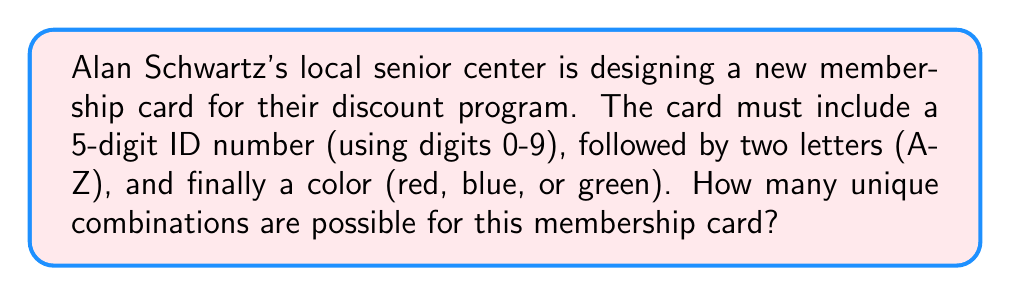What is the answer to this math problem? Let's break this down step-by-step:

1) For the 5-digit ID number:
   - We can use any digit from 0 to 9 for each position.
   - This is a case of permutation with repetition allowed.
   - Number of possibilities = $10^5$

2) For the two letters:
   - We can use any letter from A to Z for each position.
   - This is also a permutation with repetition allowed.
   - Number of possibilities = $26^2$

3) For the color:
   - We have 3 choices: red, blue, or green.
   - Number of possibilities = $3$

4) To find the total number of unique combinations, we multiply these together:

   $$ \text{Total combinations} = 10^5 \times 26^2 \times 3 $$

5) Let's calculate this:
   $$ 10^5 \times 26^2 \times 3 = 100,000 \times 676 \times 3 = 202,800,000 $$

Therefore, there are 202,800,000 unique combinations possible for the membership card.
Answer: 202,800,000 